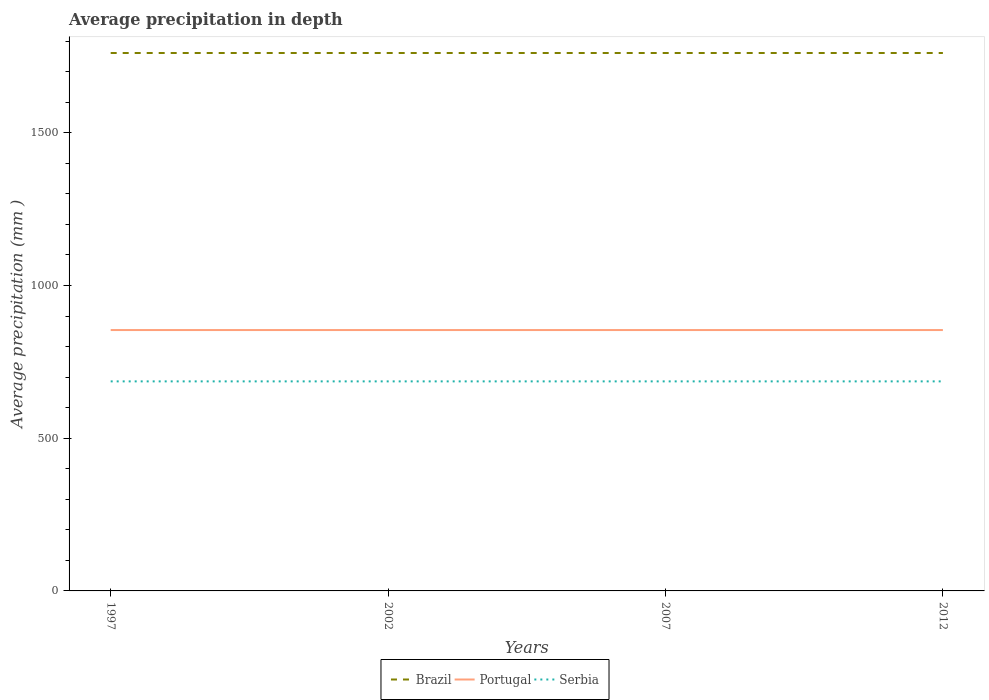How many different coloured lines are there?
Give a very brief answer. 3. Across all years, what is the maximum average precipitation in Portugal?
Keep it short and to the point. 854. In which year was the average precipitation in Serbia maximum?
Your answer should be very brief. 1997. What is the total average precipitation in Serbia in the graph?
Your answer should be very brief. 0. How many years are there in the graph?
Offer a terse response. 4. What is the difference between two consecutive major ticks on the Y-axis?
Give a very brief answer. 500. Does the graph contain grids?
Keep it short and to the point. No. Where does the legend appear in the graph?
Offer a very short reply. Bottom center. How many legend labels are there?
Make the answer very short. 3. What is the title of the graph?
Provide a short and direct response. Average precipitation in depth. What is the label or title of the Y-axis?
Your answer should be very brief. Average precipitation (mm ). What is the Average precipitation (mm ) of Brazil in 1997?
Ensure brevity in your answer.  1761. What is the Average precipitation (mm ) of Portugal in 1997?
Give a very brief answer. 854. What is the Average precipitation (mm ) in Serbia in 1997?
Offer a very short reply. 686. What is the Average precipitation (mm ) in Brazil in 2002?
Ensure brevity in your answer.  1761. What is the Average precipitation (mm ) in Portugal in 2002?
Your answer should be compact. 854. What is the Average precipitation (mm ) of Serbia in 2002?
Your response must be concise. 686. What is the Average precipitation (mm ) in Brazil in 2007?
Your answer should be compact. 1761. What is the Average precipitation (mm ) in Portugal in 2007?
Your answer should be very brief. 854. What is the Average precipitation (mm ) in Serbia in 2007?
Your answer should be compact. 686. What is the Average precipitation (mm ) in Brazil in 2012?
Ensure brevity in your answer.  1761. What is the Average precipitation (mm ) of Portugal in 2012?
Your response must be concise. 854. What is the Average precipitation (mm ) in Serbia in 2012?
Provide a short and direct response. 686. Across all years, what is the maximum Average precipitation (mm ) of Brazil?
Your answer should be very brief. 1761. Across all years, what is the maximum Average precipitation (mm ) in Portugal?
Keep it short and to the point. 854. Across all years, what is the maximum Average precipitation (mm ) in Serbia?
Make the answer very short. 686. Across all years, what is the minimum Average precipitation (mm ) of Brazil?
Provide a short and direct response. 1761. Across all years, what is the minimum Average precipitation (mm ) of Portugal?
Provide a short and direct response. 854. Across all years, what is the minimum Average precipitation (mm ) in Serbia?
Your answer should be very brief. 686. What is the total Average precipitation (mm ) in Brazil in the graph?
Provide a succinct answer. 7044. What is the total Average precipitation (mm ) of Portugal in the graph?
Ensure brevity in your answer.  3416. What is the total Average precipitation (mm ) in Serbia in the graph?
Offer a terse response. 2744. What is the difference between the Average precipitation (mm ) in Serbia in 1997 and that in 2002?
Offer a terse response. 0. What is the difference between the Average precipitation (mm ) in Portugal in 1997 and that in 2007?
Your answer should be compact. 0. What is the difference between the Average precipitation (mm ) of Brazil in 1997 and that in 2012?
Your response must be concise. 0. What is the difference between the Average precipitation (mm ) of Portugal in 1997 and that in 2012?
Give a very brief answer. 0. What is the difference between the Average precipitation (mm ) in Serbia in 1997 and that in 2012?
Offer a terse response. 0. What is the difference between the Average precipitation (mm ) in Brazil in 2002 and that in 2012?
Ensure brevity in your answer.  0. What is the difference between the Average precipitation (mm ) of Portugal in 2002 and that in 2012?
Provide a succinct answer. 0. What is the difference between the Average precipitation (mm ) in Serbia in 2002 and that in 2012?
Your response must be concise. 0. What is the difference between the Average precipitation (mm ) of Brazil in 2007 and that in 2012?
Ensure brevity in your answer.  0. What is the difference between the Average precipitation (mm ) in Portugal in 2007 and that in 2012?
Provide a succinct answer. 0. What is the difference between the Average precipitation (mm ) of Serbia in 2007 and that in 2012?
Provide a succinct answer. 0. What is the difference between the Average precipitation (mm ) in Brazil in 1997 and the Average precipitation (mm ) in Portugal in 2002?
Make the answer very short. 907. What is the difference between the Average precipitation (mm ) in Brazil in 1997 and the Average precipitation (mm ) in Serbia in 2002?
Give a very brief answer. 1075. What is the difference between the Average precipitation (mm ) in Portugal in 1997 and the Average precipitation (mm ) in Serbia in 2002?
Provide a succinct answer. 168. What is the difference between the Average precipitation (mm ) in Brazil in 1997 and the Average precipitation (mm ) in Portugal in 2007?
Keep it short and to the point. 907. What is the difference between the Average precipitation (mm ) of Brazil in 1997 and the Average precipitation (mm ) of Serbia in 2007?
Offer a terse response. 1075. What is the difference between the Average precipitation (mm ) of Portugal in 1997 and the Average precipitation (mm ) of Serbia in 2007?
Offer a terse response. 168. What is the difference between the Average precipitation (mm ) of Brazil in 1997 and the Average precipitation (mm ) of Portugal in 2012?
Keep it short and to the point. 907. What is the difference between the Average precipitation (mm ) of Brazil in 1997 and the Average precipitation (mm ) of Serbia in 2012?
Your answer should be very brief. 1075. What is the difference between the Average precipitation (mm ) in Portugal in 1997 and the Average precipitation (mm ) in Serbia in 2012?
Your answer should be compact. 168. What is the difference between the Average precipitation (mm ) of Brazil in 2002 and the Average precipitation (mm ) of Portugal in 2007?
Your answer should be compact. 907. What is the difference between the Average precipitation (mm ) of Brazil in 2002 and the Average precipitation (mm ) of Serbia in 2007?
Your answer should be compact. 1075. What is the difference between the Average precipitation (mm ) of Portugal in 2002 and the Average precipitation (mm ) of Serbia in 2007?
Ensure brevity in your answer.  168. What is the difference between the Average precipitation (mm ) of Brazil in 2002 and the Average precipitation (mm ) of Portugal in 2012?
Keep it short and to the point. 907. What is the difference between the Average precipitation (mm ) in Brazil in 2002 and the Average precipitation (mm ) in Serbia in 2012?
Give a very brief answer. 1075. What is the difference between the Average precipitation (mm ) in Portugal in 2002 and the Average precipitation (mm ) in Serbia in 2012?
Offer a very short reply. 168. What is the difference between the Average precipitation (mm ) in Brazil in 2007 and the Average precipitation (mm ) in Portugal in 2012?
Provide a succinct answer. 907. What is the difference between the Average precipitation (mm ) in Brazil in 2007 and the Average precipitation (mm ) in Serbia in 2012?
Your response must be concise. 1075. What is the difference between the Average precipitation (mm ) in Portugal in 2007 and the Average precipitation (mm ) in Serbia in 2012?
Your answer should be compact. 168. What is the average Average precipitation (mm ) of Brazil per year?
Provide a short and direct response. 1761. What is the average Average precipitation (mm ) in Portugal per year?
Give a very brief answer. 854. What is the average Average precipitation (mm ) of Serbia per year?
Provide a succinct answer. 686. In the year 1997, what is the difference between the Average precipitation (mm ) of Brazil and Average precipitation (mm ) of Portugal?
Provide a short and direct response. 907. In the year 1997, what is the difference between the Average precipitation (mm ) in Brazil and Average precipitation (mm ) in Serbia?
Ensure brevity in your answer.  1075. In the year 1997, what is the difference between the Average precipitation (mm ) of Portugal and Average precipitation (mm ) of Serbia?
Provide a short and direct response. 168. In the year 2002, what is the difference between the Average precipitation (mm ) in Brazil and Average precipitation (mm ) in Portugal?
Offer a very short reply. 907. In the year 2002, what is the difference between the Average precipitation (mm ) in Brazil and Average precipitation (mm ) in Serbia?
Your answer should be compact. 1075. In the year 2002, what is the difference between the Average precipitation (mm ) of Portugal and Average precipitation (mm ) of Serbia?
Give a very brief answer. 168. In the year 2007, what is the difference between the Average precipitation (mm ) of Brazil and Average precipitation (mm ) of Portugal?
Give a very brief answer. 907. In the year 2007, what is the difference between the Average precipitation (mm ) of Brazil and Average precipitation (mm ) of Serbia?
Ensure brevity in your answer.  1075. In the year 2007, what is the difference between the Average precipitation (mm ) in Portugal and Average precipitation (mm ) in Serbia?
Keep it short and to the point. 168. In the year 2012, what is the difference between the Average precipitation (mm ) of Brazil and Average precipitation (mm ) of Portugal?
Ensure brevity in your answer.  907. In the year 2012, what is the difference between the Average precipitation (mm ) of Brazil and Average precipitation (mm ) of Serbia?
Your answer should be compact. 1075. In the year 2012, what is the difference between the Average precipitation (mm ) in Portugal and Average precipitation (mm ) in Serbia?
Make the answer very short. 168. What is the ratio of the Average precipitation (mm ) of Portugal in 1997 to that in 2007?
Your answer should be very brief. 1. What is the ratio of the Average precipitation (mm ) of Brazil in 1997 to that in 2012?
Your answer should be compact. 1. What is the ratio of the Average precipitation (mm ) in Serbia in 1997 to that in 2012?
Give a very brief answer. 1. What is the ratio of the Average precipitation (mm ) of Brazil in 2002 to that in 2007?
Provide a short and direct response. 1. What is the ratio of the Average precipitation (mm ) of Portugal in 2002 to that in 2007?
Provide a succinct answer. 1. What is the ratio of the Average precipitation (mm ) in Serbia in 2002 to that in 2007?
Your answer should be very brief. 1. What is the ratio of the Average precipitation (mm ) in Brazil in 2002 to that in 2012?
Your answer should be very brief. 1. What is the ratio of the Average precipitation (mm ) of Portugal in 2002 to that in 2012?
Give a very brief answer. 1. What is the ratio of the Average precipitation (mm ) of Serbia in 2002 to that in 2012?
Ensure brevity in your answer.  1. What is the ratio of the Average precipitation (mm ) in Brazil in 2007 to that in 2012?
Make the answer very short. 1. What is the ratio of the Average precipitation (mm ) in Portugal in 2007 to that in 2012?
Your response must be concise. 1. What is the ratio of the Average precipitation (mm ) of Serbia in 2007 to that in 2012?
Provide a succinct answer. 1. What is the difference between the highest and the lowest Average precipitation (mm ) of Brazil?
Your answer should be very brief. 0. What is the difference between the highest and the lowest Average precipitation (mm ) of Serbia?
Offer a terse response. 0. 